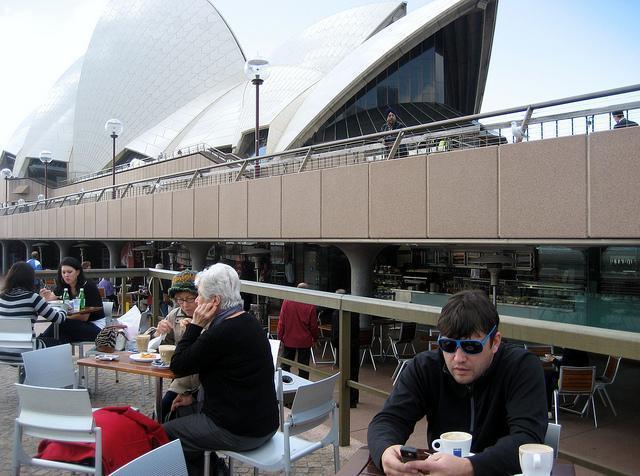How many chairs are there?
Give a very brief answer. 2. How many people are in the picture?
Give a very brief answer. 5. 